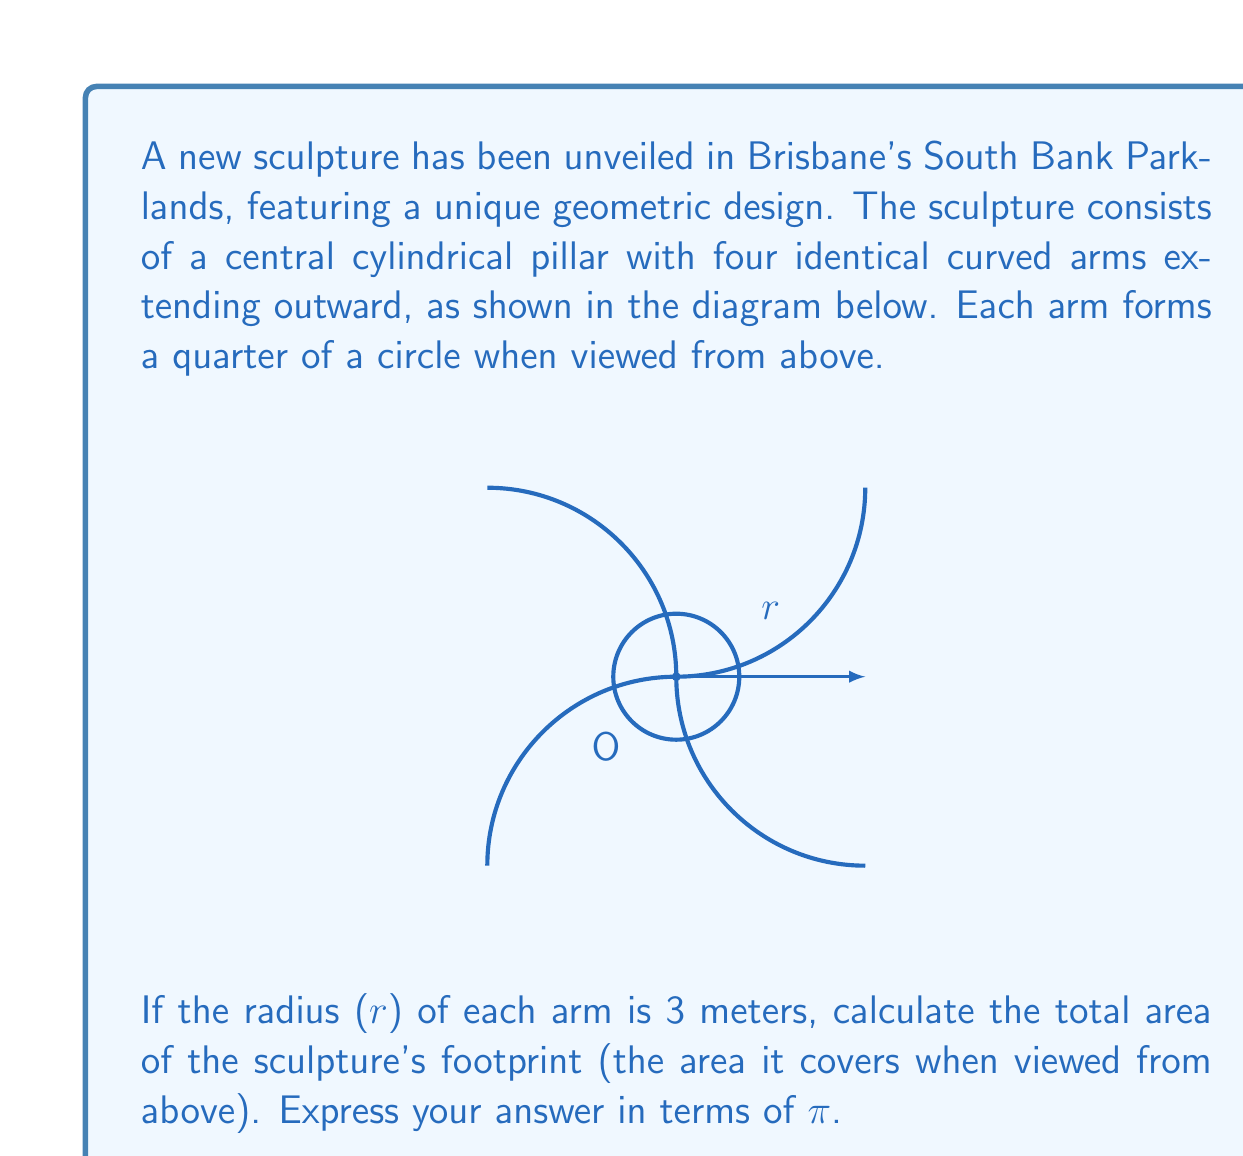Could you help me with this problem? Let's approach this step-by-step:

1) The sculpture consists of five parts: the central circle and four identical arms.

2) For the central circle:
   - Area of central circle = $\pi r^2$ = $\pi (1)^2$ = $\pi$ m²

3) For each arm:
   - Each arm forms a quarter of a circle (90°)
   - Area of a full circle with radius 3m = $\pi r^2$ = $\pi (3)^2$ = $9\pi$ m²
   - Area of each arm = $\frac{1}{4} \times 9\pi$ = $\frac{9\pi}{4}$ m²

4) Total area of all four arms:
   - $4 \times \frac{9\pi}{4}$ = $9\pi$ m²

5) Total area of the sculpture's footprint:
   - Area of central circle + Area of all four arms
   - $\pi + 9\pi$ = $10\pi$ m²

Therefore, the total area of the sculpture's footprint is $10\pi$ square meters.
Answer: $10\pi$ m² 